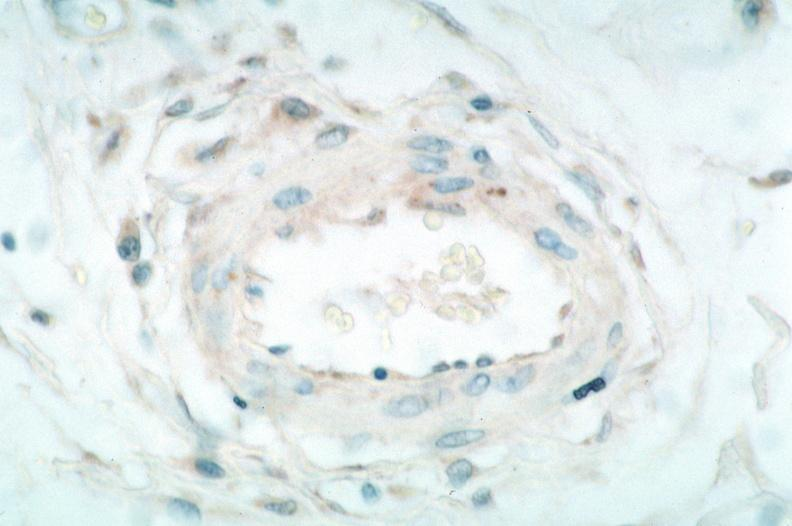does this image show vasculitis?
Answer the question using a single word or phrase. Yes 